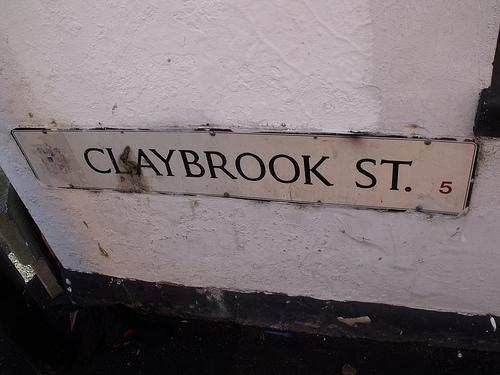Question: what color is the wall?
Choices:
A. Blue.
B. White.
C. Green.
D. Orange.
Answer with the letter. Answer: B Question: what is turned on?
Choices:
A. The computer.
B. The television.
C. The light.
D. The flashlight.
Answer with the letter. Answer: C Question: how many people are there?
Choices:
A. Ten.
B. None.
C. Four.
D. Six.
Answer with the letter. Answer: B Question: what does the sign say?
Choices:
A. Fast St.
B. Claybrook St.
C. Stevens St.
D. Richard St.
Answer with the letter. Answer: B 